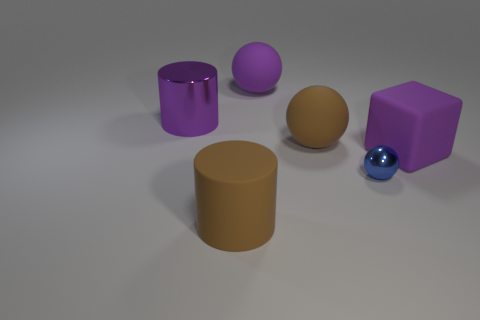Add 2 cubes. How many objects exist? 8 Subtract all rubber balls. Subtract all purple cylinders. How many objects are left? 3 Add 4 tiny spheres. How many tiny spheres are left? 5 Add 5 purple rubber things. How many purple rubber things exist? 7 Subtract 1 blue balls. How many objects are left? 5 Subtract all blocks. How many objects are left? 5 